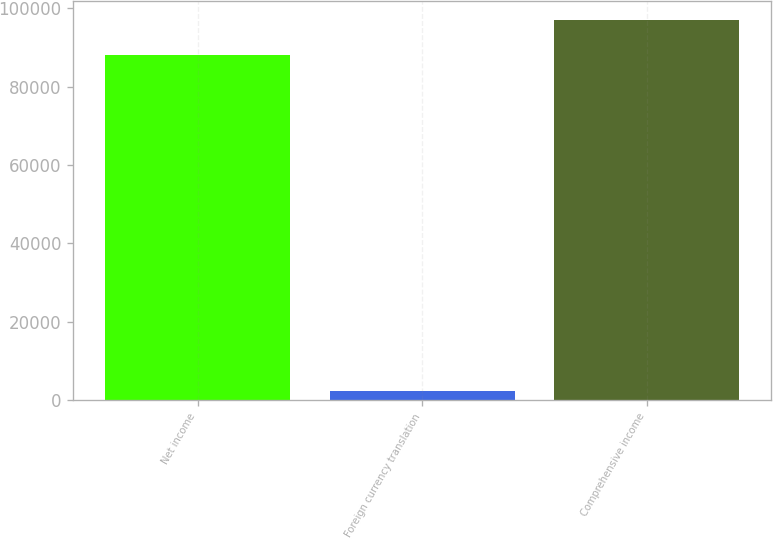Convert chart to OTSL. <chart><loc_0><loc_0><loc_500><loc_500><bar_chart><fcel>Net income<fcel>Foreign currency translation<fcel>Comprehensive income<nl><fcel>88211<fcel>2250<fcel>97032.1<nl></chart> 